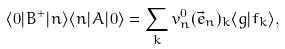Convert formula to latex. <formula><loc_0><loc_0><loc_500><loc_500>\langle 0 | { B } ^ { + } | n \rangle \langle n | { A } | 0 \rangle = \sum _ { k } v _ { n } ^ { 0 } ( \vec { e } _ { n } ) _ { k } \langle g | f _ { k } \rangle ,</formula> 